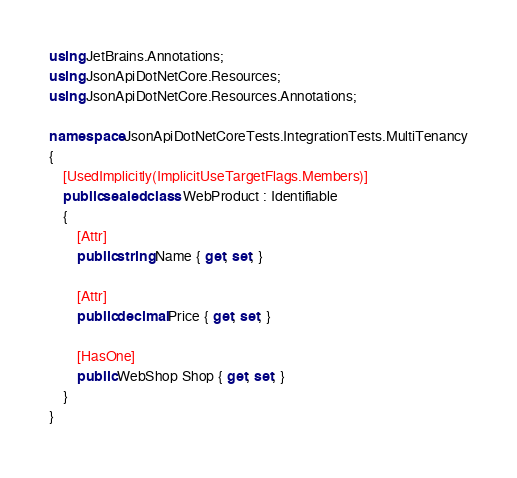Convert code to text. <code><loc_0><loc_0><loc_500><loc_500><_C#_>using JetBrains.Annotations;
using JsonApiDotNetCore.Resources;
using JsonApiDotNetCore.Resources.Annotations;

namespace JsonApiDotNetCoreTests.IntegrationTests.MultiTenancy
{
    [UsedImplicitly(ImplicitUseTargetFlags.Members)]
    public sealed class WebProduct : Identifiable
    {
        [Attr]
        public string Name { get; set; }

        [Attr]
        public decimal Price { get; set; }

        [HasOne]
        public WebShop Shop { get; set; }
    }
}
</code> 